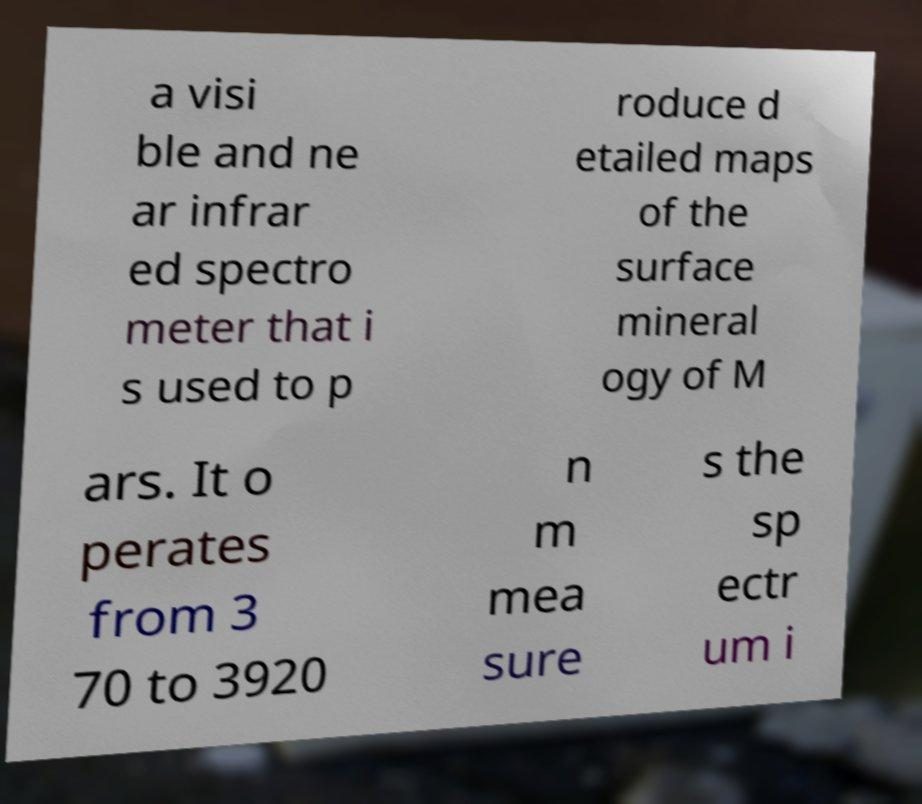Please read and relay the text visible in this image. What does it say? a visi ble and ne ar infrar ed spectro meter that i s used to p roduce d etailed maps of the surface mineral ogy of M ars. It o perates from 3 70 to 3920 n m mea sure s the sp ectr um i 